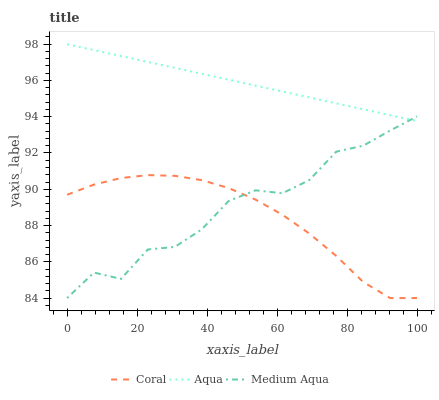Does Coral have the minimum area under the curve?
Answer yes or no. Yes. Does Aqua have the maximum area under the curve?
Answer yes or no. Yes. Does Aqua have the minimum area under the curve?
Answer yes or no. No. Does Coral have the maximum area under the curve?
Answer yes or no. No. Is Aqua the smoothest?
Answer yes or no. Yes. Is Medium Aqua the roughest?
Answer yes or no. Yes. Is Coral the smoothest?
Answer yes or no. No. Is Coral the roughest?
Answer yes or no. No. Does Medium Aqua have the lowest value?
Answer yes or no. Yes. Does Aqua have the lowest value?
Answer yes or no. No. Does Aqua have the highest value?
Answer yes or no. Yes. Does Coral have the highest value?
Answer yes or no. No. Is Coral less than Aqua?
Answer yes or no. Yes. Is Aqua greater than Coral?
Answer yes or no. Yes. Does Medium Aqua intersect Aqua?
Answer yes or no. Yes. Is Medium Aqua less than Aqua?
Answer yes or no. No. Is Medium Aqua greater than Aqua?
Answer yes or no. No. Does Coral intersect Aqua?
Answer yes or no. No. 